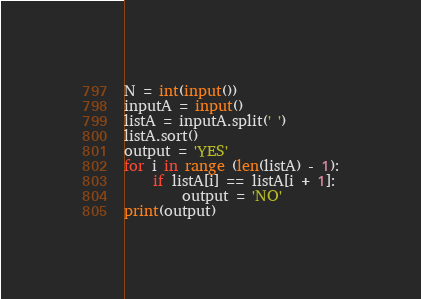<code> <loc_0><loc_0><loc_500><loc_500><_Python_>N = int(input())
inputA = input()
listA = inputA.split(' ')
listA.sort()
output = 'YES'
for i in range (len(listA) - 1):
    if listA[i] == listA[i + 1]:
        output = 'NO'
print(output)</code> 